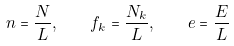<formula> <loc_0><loc_0><loc_500><loc_500>n = \frac { N } { L } , \quad f _ { k } = \frac { N _ { k } } { L } , \quad e = \frac { E } { L }</formula> 